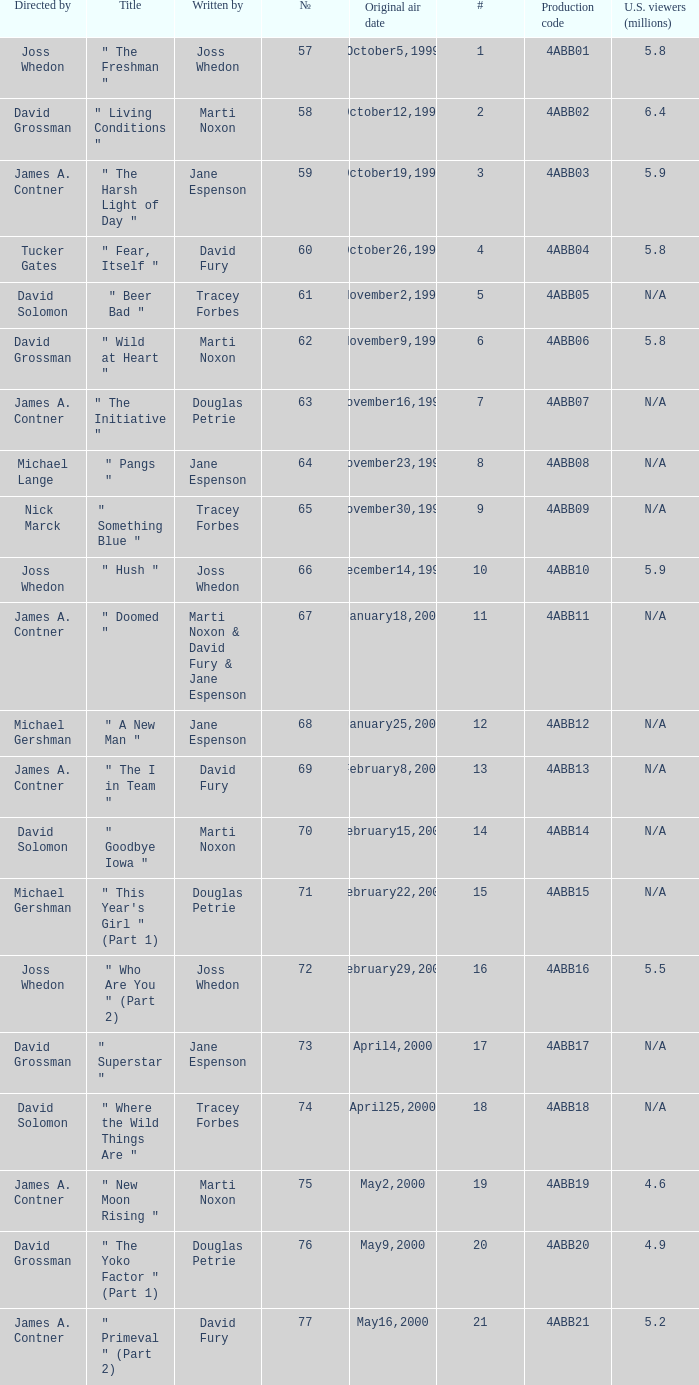Who wrote the episode which was directed by Nick Marck? Tracey Forbes. 